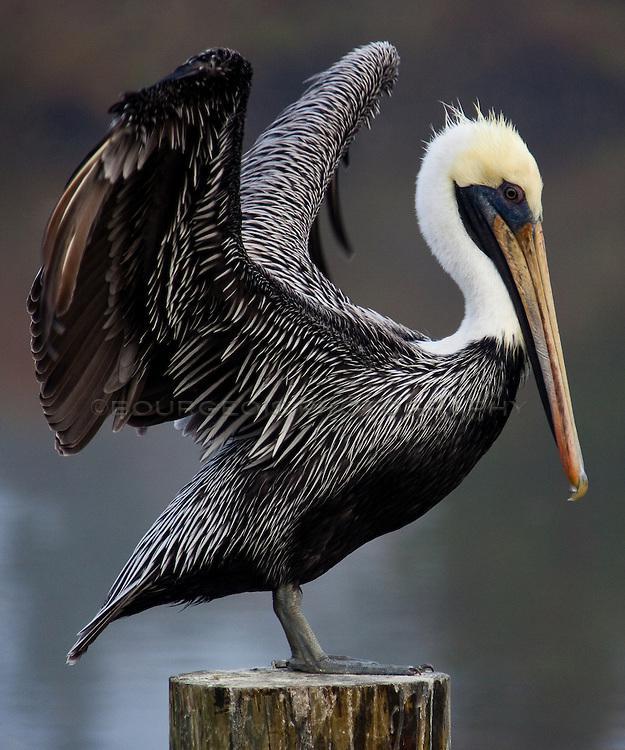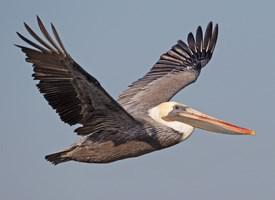The first image is the image on the left, the second image is the image on the right. Evaluate the accuracy of this statement regarding the images: "The right image shows a pelican afloat on the water.". Is it true? Answer yes or no. No. 